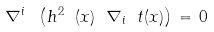<formula> <loc_0><loc_0><loc_500><loc_500>\nabla ^ { i } \ \left ( h ^ { 2 } \ ( x ) \ \nabla _ { i } \ t ( x ) \right ) \, = \, 0</formula> 